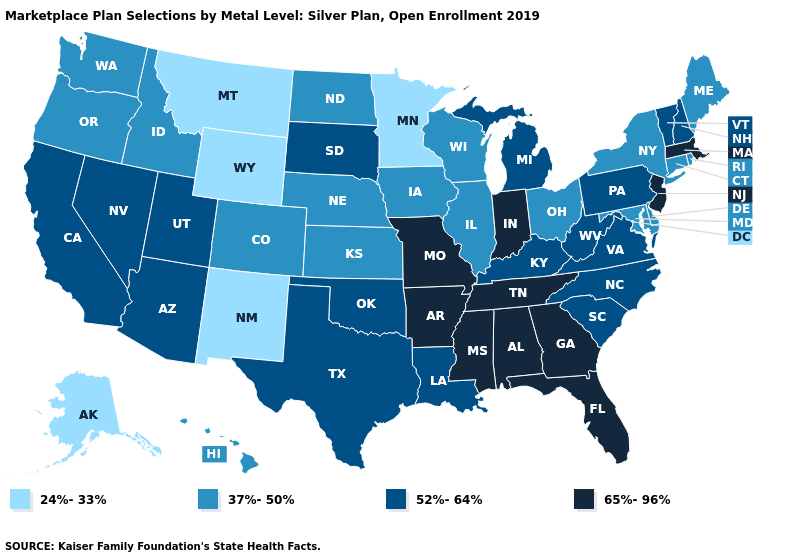Name the states that have a value in the range 37%-50%?
Answer briefly. Colorado, Connecticut, Delaware, Hawaii, Idaho, Illinois, Iowa, Kansas, Maine, Maryland, Nebraska, New York, North Dakota, Ohio, Oregon, Rhode Island, Washington, Wisconsin. What is the value of Arizona?
Keep it brief. 52%-64%. What is the value of Ohio?
Concise answer only. 37%-50%. What is the value of South Carolina?
Write a very short answer. 52%-64%. Which states hav the highest value in the Northeast?
Write a very short answer. Massachusetts, New Jersey. Does the map have missing data?
Concise answer only. No. What is the value of Wisconsin?
Quick response, please. 37%-50%. Among the states that border Tennessee , which have the lowest value?
Give a very brief answer. Kentucky, North Carolina, Virginia. What is the lowest value in the Northeast?
Be succinct. 37%-50%. What is the value of Texas?
Short answer required. 52%-64%. What is the highest value in the USA?
Be succinct. 65%-96%. Does the first symbol in the legend represent the smallest category?
Concise answer only. Yes. Name the states that have a value in the range 65%-96%?
Give a very brief answer. Alabama, Arkansas, Florida, Georgia, Indiana, Massachusetts, Mississippi, Missouri, New Jersey, Tennessee. What is the lowest value in states that border Texas?
Concise answer only. 24%-33%. Is the legend a continuous bar?
Be succinct. No. 